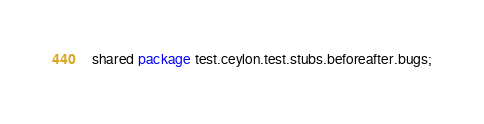<code> <loc_0><loc_0><loc_500><loc_500><_Ceylon_>shared package test.ceylon.test.stubs.beforeafter.bugs;
</code> 